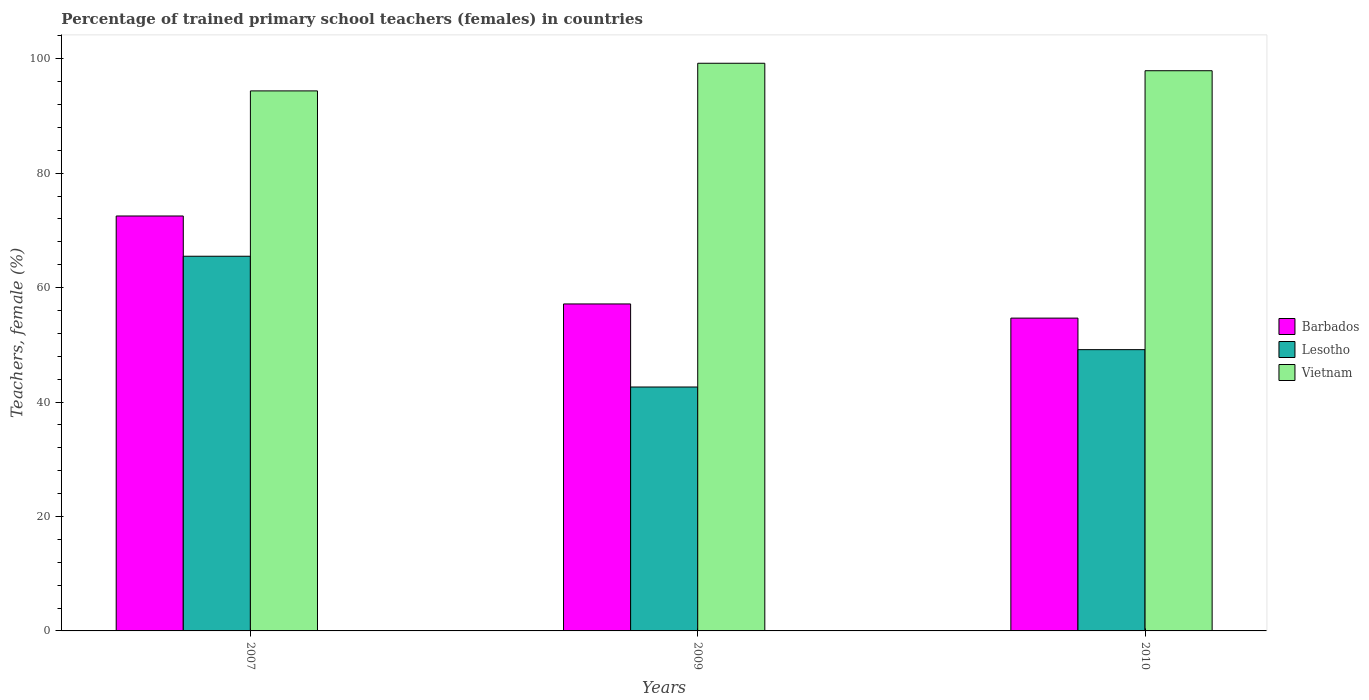How many groups of bars are there?
Offer a terse response. 3. How many bars are there on the 1st tick from the right?
Your answer should be compact. 3. In how many cases, is the number of bars for a given year not equal to the number of legend labels?
Make the answer very short. 0. What is the percentage of trained primary school teachers (females) in Barbados in 2007?
Your answer should be very brief. 72.51. Across all years, what is the maximum percentage of trained primary school teachers (females) in Vietnam?
Your answer should be very brief. 99.21. Across all years, what is the minimum percentage of trained primary school teachers (females) in Vietnam?
Your answer should be compact. 94.37. In which year was the percentage of trained primary school teachers (females) in Barbados maximum?
Provide a short and direct response. 2007. In which year was the percentage of trained primary school teachers (females) in Lesotho minimum?
Give a very brief answer. 2009. What is the total percentage of trained primary school teachers (females) in Lesotho in the graph?
Provide a succinct answer. 157.26. What is the difference between the percentage of trained primary school teachers (females) in Vietnam in 2007 and that in 2009?
Offer a very short reply. -4.83. What is the difference between the percentage of trained primary school teachers (females) in Barbados in 2007 and the percentage of trained primary school teachers (females) in Lesotho in 2009?
Offer a very short reply. 29.89. What is the average percentage of trained primary school teachers (females) in Vietnam per year?
Ensure brevity in your answer.  97.16. In the year 2007, what is the difference between the percentage of trained primary school teachers (females) in Lesotho and percentage of trained primary school teachers (females) in Barbados?
Provide a succinct answer. -7.04. In how many years, is the percentage of trained primary school teachers (females) in Lesotho greater than 64 %?
Your answer should be very brief. 1. What is the ratio of the percentage of trained primary school teachers (females) in Lesotho in 2007 to that in 2010?
Give a very brief answer. 1.33. Is the percentage of trained primary school teachers (females) in Barbados in 2007 less than that in 2010?
Your response must be concise. No. What is the difference between the highest and the second highest percentage of trained primary school teachers (females) in Vietnam?
Provide a succinct answer. 1.31. What is the difference between the highest and the lowest percentage of trained primary school teachers (females) in Barbados?
Ensure brevity in your answer.  17.85. In how many years, is the percentage of trained primary school teachers (females) in Barbados greater than the average percentage of trained primary school teachers (females) in Barbados taken over all years?
Provide a succinct answer. 1. Is the sum of the percentage of trained primary school teachers (females) in Barbados in 2007 and 2010 greater than the maximum percentage of trained primary school teachers (females) in Lesotho across all years?
Your answer should be very brief. Yes. What does the 2nd bar from the left in 2009 represents?
Provide a short and direct response. Lesotho. What does the 1st bar from the right in 2007 represents?
Ensure brevity in your answer.  Vietnam. Is it the case that in every year, the sum of the percentage of trained primary school teachers (females) in Vietnam and percentage of trained primary school teachers (females) in Lesotho is greater than the percentage of trained primary school teachers (females) in Barbados?
Keep it short and to the point. Yes. How many bars are there?
Your response must be concise. 9. Are all the bars in the graph horizontal?
Your response must be concise. No. What is the difference between two consecutive major ticks on the Y-axis?
Provide a short and direct response. 20. Are the values on the major ticks of Y-axis written in scientific E-notation?
Keep it short and to the point. No. Where does the legend appear in the graph?
Offer a terse response. Center right. What is the title of the graph?
Provide a succinct answer. Percentage of trained primary school teachers (females) in countries. Does "Bhutan" appear as one of the legend labels in the graph?
Provide a succinct answer. No. What is the label or title of the X-axis?
Your answer should be compact. Years. What is the label or title of the Y-axis?
Your response must be concise. Teachers, female (%). What is the Teachers, female (%) of Barbados in 2007?
Make the answer very short. 72.51. What is the Teachers, female (%) in Lesotho in 2007?
Your response must be concise. 65.48. What is the Teachers, female (%) in Vietnam in 2007?
Offer a very short reply. 94.37. What is the Teachers, female (%) in Barbados in 2009?
Your answer should be very brief. 57.14. What is the Teachers, female (%) in Lesotho in 2009?
Ensure brevity in your answer.  42.63. What is the Teachers, female (%) of Vietnam in 2009?
Offer a terse response. 99.21. What is the Teachers, female (%) in Barbados in 2010?
Keep it short and to the point. 54.67. What is the Teachers, female (%) in Lesotho in 2010?
Offer a very short reply. 49.15. What is the Teachers, female (%) of Vietnam in 2010?
Offer a very short reply. 97.9. Across all years, what is the maximum Teachers, female (%) in Barbados?
Provide a short and direct response. 72.51. Across all years, what is the maximum Teachers, female (%) in Lesotho?
Your answer should be very brief. 65.48. Across all years, what is the maximum Teachers, female (%) of Vietnam?
Make the answer very short. 99.21. Across all years, what is the minimum Teachers, female (%) in Barbados?
Provide a short and direct response. 54.67. Across all years, what is the minimum Teachers, female (%) of Lesotho?
Your answer should be very brief. 42.63. Across all years, what is the minimum Teachers, female (%) in Vietnam?
Give a very brief answer. 94.37. What is the total Teachers, female (%) of Barbados in the graph?
Offer a very short reply. 184.32. What is the total Teachers, female (%) in Lesotho in the graph?
Make the answer very short. 157.26. What is the total Teachers, female (%) in Vietnam in the graph?
Your answer should be very brief. 291.48. What is the difference between the Teachers, female (%) of Barbados in 2007 and that in 2009?
Offer a very short reply. 15.37. What is the difference between the Teachers, female (%) of Lesotho in 2007 and that in 2009?
Make the answer very short. 22.85. What is the difference between the Teachers, female (%) of Vietnam in 2007 and that in 2009?
Provide a short and direct response. -4.83. What is the difference between the Teachers, female (%) of Barbados in 2007 and that in 2010?
Make the answer very short. 17.85. What is the difference between the Teachers, female (%) in Lesotho in 2007 and that in 2010?
Ensure brevity in your answer.  16.33. What is the difference between the Teachers, female (%) of Vietnam in 2007 and that in 2010?
Keep it short and to the point. -3.53. What is the difference between the Teachers, female (%) of Barbados in 2009 and that in 2010?
Make the answer very short. 2.48. What is the difference between the Teachers, female (%) in Lesotho in 2009 and that in 2010?
Give a very brief answer. -6.53. What is the difference between the Teachers, female (%) of Vietnam in 2009 and that in 2010?
Keep it short and to the point. 1.31. What is the difference between the Teachers, female (%) of Barbados in 2007 and the Teachers, female (%) of Lesotho in 2009?
Your response must be concise. 29.89. What is the difference between the Teachers, female (%) of Barbados in 2007 and the Teachers, female (%) of Vietnam in 2009?
Your answer should be compact. -26.69. What is the difference between the Teachers, female (%) in Lesotho in 2007 and the Teachers, female (%) in Vietnam in 2009?
Provide a short and direct response. -33.73. What is the difference between the Teachers, female (%) of Barbados in 2007 and the Teachers, female (%) of Lesotho in 2010?
Keep it short and to the point. 23.36. What is the difference between the Teachers, female (%) in Barbados in 2007 and the Teachers, female (%) in Vietnam in 2010?
Provide a short and direct response. -25.38. What is the difference between the Teachers, female (%) of Lesotho in 2007 and the Teachers, female (%) of Vietnam in 2010?
Offer a terse response. -32.42. What is the difference between the Teachers, female (%) of Barbados in 2009 and the Teachers, female (%) of Lesotho in 2010?
Give a very brief answer. 7.99. What is the difference between the Teachers, female (%) of Barbados in 2009 and the Teachers, female (%) of Vietnam in 2010?
Ensure brevity in your answer.  -40.76. What is the difference between the Teachers, female (%) of Lesotho in 2009 and the Teachers, female (%) of Vietnam in 2010?
Ensure brevity in your answer.  -55.27. What is the average Teachers, female (%) in Barbados per year?
Offer a very short reply. 61.44. What is the average Teachers, female (%) of Lesotho per year?
Provide a short and direct response. 52.42. What is the average Teachers, female (%) of Vietnam per year?
Make the answer very short. 97.16. In the year 2007, what is the difference between the Teachers, female (%) of Barbados and Teachers, female (%) of Lesotho?
Your answer should be very brief. 7.04. In the year 2007, what is the difference between the Teachers, female (%) in Barbados and Teachers, female (%) in Vietnam?
Offer a very short reply. -21.86. In the year 2007, what is the difference between the Teachers, female (%) of Lesotho and Teachers, female (%) of Vietnam?
Offer a terse response. -28.89. In the year 2009, what is the difference between the Teachers, female (%) of Barbados and Teachers, female (%) of Lesotho?
Offer a terse response. 14.52. In the year 2009, what is the difference between the Teachers, female (%) in Barbados and Teachers, female (%) in Vietnam?
Make the answer very short. -42.06. In the year 2009, what is the difference between the Teachers, female (%) of Lesotho and Teachers, female (%) of Vietnam?
Offer a terse response. -56.58. In the year 2010, what is the difference between the Teachers, female (%) of Barbados and Teachers, female (%) of Lesotho?
Your answer should be very brief. 5.51. In the year 2010, what is the difference between the Teachers, female (%) in Barbados and Teachers, female (%) in Vietnam?
Offer a terse response. -43.23. In the year 2010, what is the difference between the Teachers, female (%) of Lesotho and Teachers, female (%) of Vietnam?
Offer a very short reply. -48.74. What is the ratio of the Teachers, female (%) of Barbados in 2007 to that in 2009?
Ensure brevity in your answer.  1.27. What is the ratio of the Teachers, female (%) in Lesotho in 2007 to that in 2009?
Your answer should be compact. 1.54. What is the ratio of the Teachers, female (%) in Vietnam in 2007 to that in 2009?
Your answer should be very brief. 0.95. What is the ratio of the Teachers, female (%) in Barbados in 2007 to that in 2010?
Provide a short and direct response. 1.33. What is the ratio of the Teachers, female (%) of Lesotho in 2007 to that in 2010?
Provide a short and direct response. 1.33. What is the ratio of the Teachers, female (%) of Barbados in 2009 to that in 2010?
Your response must be concise. 1.05. What is the ratio of the Teachers, female (%) of Lesotho in 2009 to that in 2010?
Your answer should be very brief. 0.87. What is the ratio of the Teachers, female (%) in Vietnam in 2009 to that in 2010?
Offer a terse response. 1.01. What is the difference between the highest and the second highest Teachers, female (%) of Barbados?
Give a very brief answer. 15.37. What is the difference between the highest and the second highest Teachers, female (%) of Lesotho?
Your response must be concise. 16.33. What is the difference between the highest and the second highest Teachers, female (%) of Vietnam?
Ensure brevity in your answer.  1.31. What is the difference between the highest and the lowest Teachers, female (%) in Barbados?
Keep it short and to the point. 17.85. What is the difference between the highest and the lowest Teachers, female (%) of Lesotho?
Ensure brevity in your answer.  22.85. What is the difference between the highest and the lowest Teachers, female (%) of Vietnam?
Give a very brief answer. 4.83. 